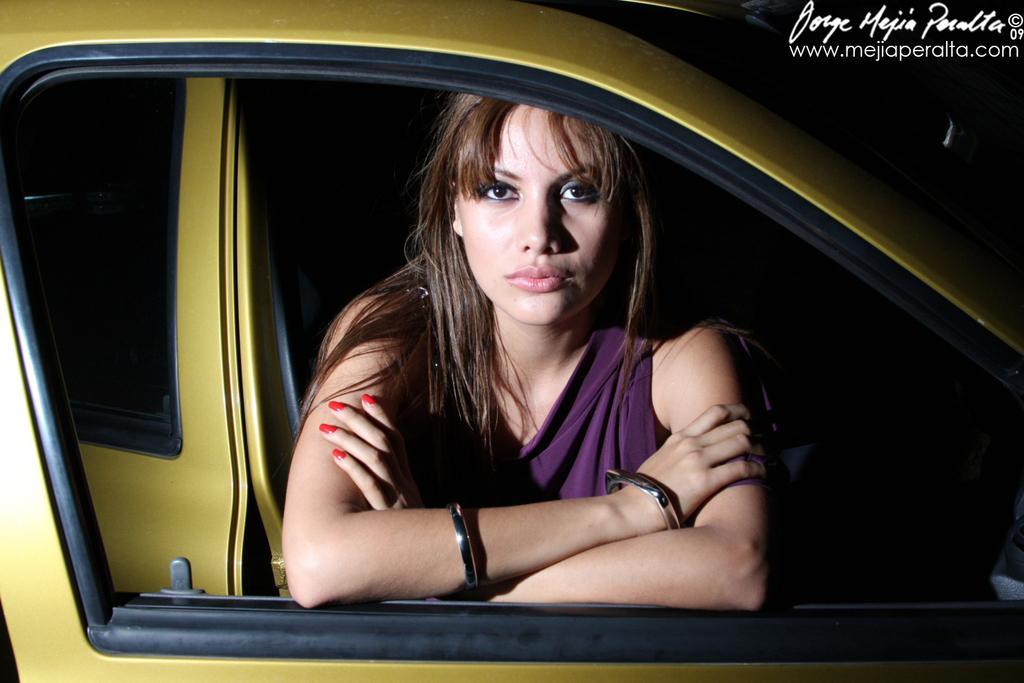How would you summarize this image in a sentence or two? In this image I see a woman who is in a vehicle. 